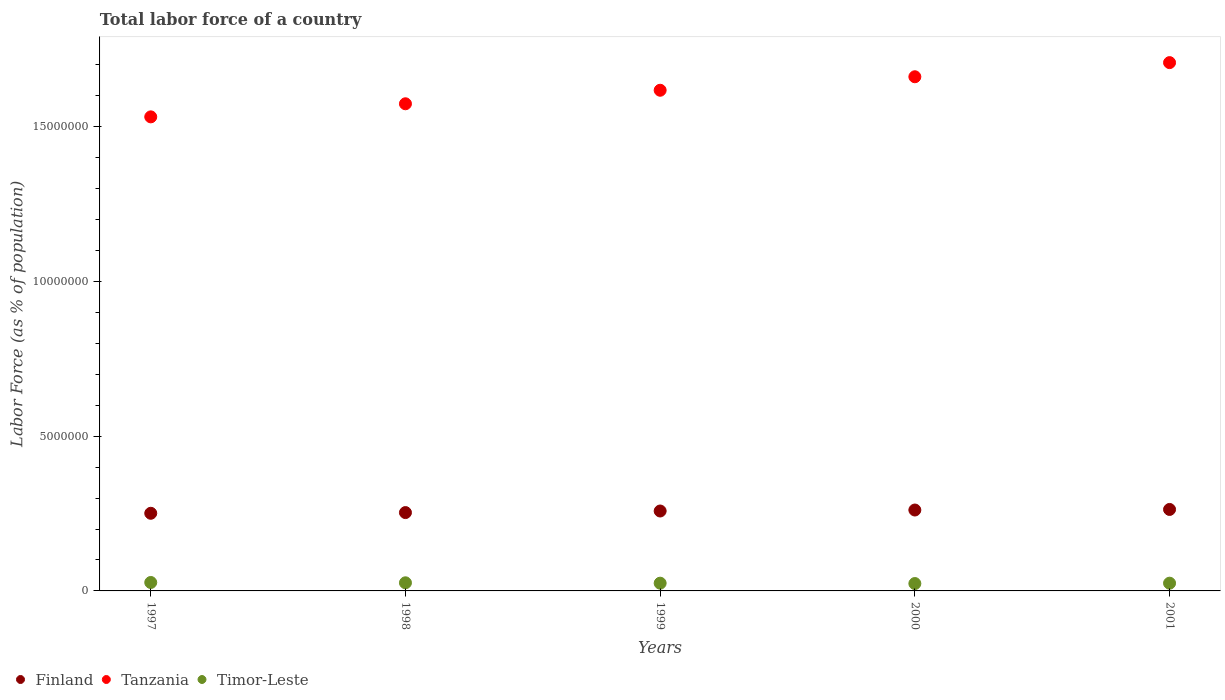What is the percentage of labor force in Tanzania in 2000?
Your response must be concise. 1.66e+07. Across all years, what is the maximum percentage of labor force in Tanzania?
Provide a short and direct response. 1.71e+07. Across all years, what is the minimum percentage of labor force in Tanzania?
Your answer should be very brief. 1.53e+07. In which year was the percentage of labor force in Tanzania maximum?
Offer a terse response. 2001. What is the total percentage of labor force in Timor-Leste in the graph?
Keep it short and to the point. 1.27e+06. What is the difference between the percentage of labor force in Tanzania in 1999 and that in 2000?
Your response must be concise. -4.36e+05. What is the difference between the percentage of labor force in Timor-Leste in 1998 and the percentage of labor force in Tanzania in 1999?
Offer a terse response. -1.59e+07. What is the average percentage of labor force in Tanzania per year?
Your answer should be very brief. 1.62e+07. In the year 1998, what is the difference between the percentage of labor force in Timor-Leste and percentage of labor force in Finland?
Provide a succinct answer. -2.27e+06. What is the ratio of the percentage of labor force in Tanzania in 1997 to that in 2000?
Offer a terse response. 0.92. Is the percentage of labor force in Finland in 1998 less than that in 2001?
Ensure brevity in your answer.  Yes. What is the difference between the highest and the second highest percentage of labor force in Timor-Leste?
Offer a very short reply. 1.02e+04. What is the difference between the highest and the lowest percentage of labor force in Tanzania?
Ensure brevity in your answer.  1.75e+06. In how many years, is the percentage of labor force in Timor-Leste greater than the average percentage of labor force in Timor-Leste taken over all years?
Your response must be concise. 2. Is the sum of the percentage of labor force in Finland in 1999 and 2000 greater than the maximum percentage of labor force in Timor-Leste across all years?
Your answer should be very brief. Yes. Does the percentage of labor force in Tanzania monotonically increase over the years?
Your response must be concise. Yes. Is the percentage of labor force in Timor-Leste strictly greater than the percentage of labor force in Tanzania over the years?
Make the answer very short. No. Is the percentage of labor force in Timor-Leste strictly less than the percentage of labor force in Finland over the years?
Your answer should be compact. Yes. How many dotlines are there?
Keep it short and to the point. 3. How many years are there in the graph?
Ensure brevity in your answer.  5. What is the difference between two consecutive major ticks on the Y-axis?
Offer a very short reply. 5.00e+06. Are the values on the major ticks of Y-axis written in scientific E-notation?
Provide a succinct answer. No. Does the graph contain any zero values?
Give a very brief answer. No. Where does the legend appear in the graph?
Ensure brevity in your answer.  Bottom left. How many legend labels are there?
Your answer should be compact. 3. What is the title of the graph?
Make the answer very short. Total labor force of a country. Does "Upper middle income" appear as one of the legend labels in the graph?
Make the answer very short. No. What is the label or title of the Y-axis?
Give a very brief answer. Labor Force (as % of population). What is the Labor Force (as % of population) of Finland in 1997?
Offer a very short reply. 2.51e+06. What is the Labor Force (as % of population) of Tanzania in 1997?
Your answer should be compact. 1.53e+07. What is the Labor Force (as % of population) in Timor-Leste in 1997?
Provide a succinct answer. 2.73e+05. What is the Labor Force (as % of population) of Finland in 1998?
Make the answer very short. 2.53e+06. What is the Labor Force (as % of population) of Tanzania in 1998?
Offer a very short reply. 1.57e+07. What is the Labor Force (as % of population) of Timor-Leste in 1998?
Keep it short and to the point. 2.62e+05. What is the Labor Force (as % of population) of Finland in 1999?
Offer a terse response. 2.58e+06. What is the Labor Force (as % of population) in Tanzania in 1999?
Your answer should be compact. 1.62e+07. What is the Labor Force (as % of population) in Timor-Leste in 1999?
Provide a short and direct response. 2.50e+05. What is the Labor Force (as % of population) in Finland in 2000?
Give a very brief answer. 2.61e+06. What is the Labor Force (as % of population) in Tanzania in 2000?
Give a very brief answer. 1.66e+07. What is the Labor Force (as % of population) of Timor-Leste in 2000?
Ensure brevity in your answer.  2.38e+05. What is the Labor Force (as % of population) of Finland in 2001?
Provide a succinct answer. 2.63e+06. What is the Labor Force (as % of population) of Tanzania in 2001?
Your answer should be very brief. 1.71e+07. What is the Labor Force (as % of population) in Timor-Leste in 2001?
Make the answer very short. 2.50e+05. Across all years, what is the maximum Labor Force (as % of population) of Finland?
Offer a terse response. 2.63e+06. Across all years, what is the maximum Labor Force (as % of population) in Tanzania?
Ensure brevity in your answer.  1.71e+07. Across all years, what is the maximum Labor Force (as % of population) of Timor-Leste?
Your response must be concise. 2.73e+05. Across all years, what is the minimum Labor Force (as % of population) in Finland?
Make the answer very short. 2.51e+06. Across all years, what is the minimum Labor Force (as % of population) of Tanzania?
Your answer should be compact. 1.53e+07. Across all years, what is the minimum Labor Force (as % of population) in Timor-Leste?
Give a very brief answer. 2.38e+05. What is the total Labor Force (as % of population) of Finland in the graph?
Make the answer very short. 1.29e+07. What is the total Labor Force (as % of population) in Tanzania in the graph?
Offer a very short reply. 8.09e+07. What is the total Labor Force (as % of population) of Timor-Leste in the graph?
Give a very brief answer. 1.27e+06. What is the difference between the Labor Force (as % of population) of Finland in 1997 and that in 1998?
Your response must be concise. -2.27e+04. What is the difference between the Labor Force (as % of population) of Tanzania in 1997 and that in 1998?
Give a very brief answer. -4.23e+05. What is the difference between the Labor Force (as % of population) in Timor-Leste in 1997 and that in 1998?
Keep it short and to the point. 1.02e+04. What is the difference between the Labor Force (as % of population) of Finland in 1997 and that in 1999?
Give a very brief answer. -7.36e+04. What is the difference between the Labor Force (as % of population) of Tanzania in 1997 and that in 1999?
Ensure brevity in your answer.  -8.60e+05. What is the difference between the Labor Force (as % of population) in Timor-Leste in 1997 and that in 1999?
Ensure brevity in your answer.  2.26e+04. What is the difference between the Labor Force (as % of population) in Finland in 1997 and that in 2000?
Keep it short and to the point. -1.06e+05. What is the difference between the Labor Force (as % of population) in Tanzania in 1997 and that in 2000?
Your response must be concise. -1.30e+06. What is the difference between the Labor Force (as % of population) of Timor-Leste in 1997 and that in 2000?
Your response must be concise. 3.43e+04. What is the difference between the Labor Force (as % of population) in Finland in 1997 and that in 2001?
Provide a short and direct response. -1.24e+05. What is the difference between the Labor Force (as % of population) of Tanzania in 1997 and that in 2001?
Offer a very short reply. -1.75e+06. What is the difference between the Labor Force (as % of population) of Timor-Leste in 1997 and that in 2001?
Provide a short and direct response. 2.25e+04. What is the difference between the Labor Force (as % of population) of Finland in 1998 and that in 1999?
Make the answer very short. -5.09e+04. What is the difference between the Labor Force (as % of population) in Tanzania in 1998 and that in 1999?
Make the answer very short. -4.37e+05. What is the difference between the Labor Force (as % of population) in Timor-Leste in 1998 and that in 1999?
Provide a short and direct response. 1.23e+04. What is the difference between the Labor Force (as % of population) of Finland in 1998 and that in 2000?
Keep it short and to the point. -8.28e+04. What is the difference between the Labor Force (as % of population) of Tanzania in 1998 and that in 2000?
Your response must be concise. -8.73e+05. What is the difference between the Labor Force (as % of population) in Timor-Leste in 1998 and that in 2000?
Offer a terse response. 2.40e+04. What is the difference between the Labor Force (as % of population) of Finland in 1998 and that in 2001?
Keep it short and to the point. -1.01e+05. What is the difference between the Labor Force (as % of population) of Tanzania in 1998 and that in 2001?
Offer a very short reply. -1.33e+06. What is the difference between the Labor Force (as % of population) in Timor-Leste in 1998 and that in 2001?
Provide a succinct answer. 1.23e+04. What is the difference between the Labor Force (as % of population) in Finland in 1999 and that in 2000?
Give a very brief answer. -3.19e+04. What is the difference between the Labor Force (as % of population) of Tanzania in 1999 and that in 2000?
Give a very brief answer. -4.36e+05. What is the difference between the Labor Force (as % of population) in Timor-Leste in 1999 and that in 2000?
Ensure brevity in your answer.  1.17e+04. What is the difference between the Labor Force (as % of population) in Finland in 1999 and that in 2001?
Give a very brief answer. -5.03e+04. What is the difference between the Labor Force (as % of population) in Tanzania in 1999 and that in 2001?
Offer a terse response. -8.93e+05. What is the difference between the Labor Force (as % of population) in Finland in 2000 and that in 2001?
Your answer should be very brief. -1.84e+04. What is the difference between the Labor Force (as % of population) in Tanzania in 2000 and that in 2001?
Provide a succinct answer. -4.57e+05. What is the difference between the Labor Force (as % of population) in Timor-Leste in 2000 and that in 2001?
Offer a terse response. -1.17e+04. What is the difference between the Labor Force (as % of population) of Finland in 1997 and the Labor Force (as % of population) of Tanzania in 1998?
Your response must be concise. -1.32e+07. What is the difference between the Labor Force (as % of population) in Finland in 1997 and the Labor Force (as % of population) in Timor-Leste in 1998?
Your response must be concise. 2.25e+06. What is the difference between the Labor Force (as % of population) of Tanzania in 1997 and the Labor Force (as % of population) of Timor-Leste in 1998?
Make the answer very short. 1.51e+07. What is the difference between the Labor Force (as % of population) in Finland in 1997 and the Labor Force (as % of population) in Tanzania in 1999?
Ensure brevity in your answer.  -1.37e+07. What is the difference between the Labor Force (as % of population) in Finland in 1997 and the Labor Force (as % of population) in Timor-Leste in 1999?
Provide a short and direct response. 2.26e+06. What is the difference between the Labor Force (as % of population) of Tanzania in 1997 and the Labor Force (as % of population) of Timor-Leste in 1999?
Ensure brevity in your answer.  1.51e+07. What is the difference between the Labor Force (as % of population) of Finland in 1997 and the Labor Force (as % of population) of Tanzania in 2000?
Offer a very short reply. -1.41e+07. What is the difference between the Labor Force (as % of population) in Finland in 1997 and the Labor Force (as % of population) in Timor-Leste in 2000?
Keep it short and to the point. 2.27e+06. What is the difference between the Labor Force (as % of population) in Tanzania in 1997 and the Labor Force (as % of population) in Timor-Leste in 2000?
Your answer should be very brief. 1.51e+07. What is the difference between the Labor Force (as % of population) in Finland in 1997 and the Labor Force (as % of population) in Tanzania in 2001?
Keep it short and to the point. -1.46e+07. What is the difference between the Labor Force (as % of population) of Finland in 1997 and the Labor Force (as % of population) of Timor-Leste in 2001?
Your answer should be very brief. 2.26e+06. What is the difference between the Labor Force (as % of population) of Tanzania in 1997 and the Labor Force (as % of population) of Timor-Leste in 2001?
Your response must be concise. 1.51e+07. What is the difference between the Labor Force (as % of population) of Finland in 1998 and the Labor Force (as % of population) of Tanzania in 1999?
Offer a terse response. -1.36e+07. What is the difference between the Labor Force (as % of population) in Finland in 1998 and the Labor Force (as % of population) in Timor-Leste in 1999?
Your answer should be very brief. 2.28e+06. What is the difference between the Labor Force (as % of population) in Tanzania in 1998 and the Labor Force (as % of population) in Timor-Leste in 1999?
Your answer should be very brief. 1.55e+07. What is the difference between the Labor Force (as % of population) in Finland in 1998 and the Labor Force (as % of population) in Tanzania in 2000?
Offer a very short reply. -1.41e+07. What is the difference between the Labor Force (as % of population) in Finland in 1998 and the Labor Force (as % of population) in Timor-Leste in 2000?
Your answer should be very brief. 2.29e+06. What is the difference between the Labor Force (as % of population) in Tanzania in 1998 and the Labor Force (as % of population) in Timor-Leste in 2000?
Your response must be concise. 1.55e+07. What is the difference between the Labor Force (as % of population) of Finland in 1998 and the Labor Force (as % of population) of Tanzania in 2001?
Ensure brevity in your answer.  -1.45e+07. What is the difference between the Labor Force (as % of population) of Finland in 1998 and the Labor Force (as % of population) of Timor-Leste in 2001?
Your response must be concise. 2.28e+06. What is the difference between the Labor Force (as % of population) in Tanzania in 1998 and the Labor Force (as % of population) in Timor-Leste in 2001?
Offer a very short reply. 1.55e+07. What is the difference between the Labor Force (as % of population) in Finland in 1999 and the Labor Force (as % of population) in Tanzania in 2000?
Your answer should be very brief. -1.40e+07. What is the difference between the Labor Force (as % of population) in Finland in 1999 and the Labor Force (as % of population) in Timor-Leste in 2000?
Give a very brief answer. 2.34e+06. What is the difference between the Labor Force (as % of population) of Tanzania in 1999 and the Labor Force (as % of population) of Timor-Leste in 2000?
Offer a terse response. 1.59e+07. What is the difference between the Labor Force (as % of population) in Finland in 1999 and the Labor Force (as % of population) in Tanzania in 2001?
Keep it short and to the point. -1.45e+07. What is the difference between the Labor Force (as % of population) in Finland in 1999 and the Labor Force (as % of population) in Timor-Leste in 2001?
Provide a succinct answer. 2.33e+06. What is the difference between the Labor Force (as % of population) in Tanzania in 1999 and the Labor Force (as % of population) in Timor-Leste in 2001?
Make the answer very short. 1.59e+07. What is the difference between the Labor Force (as % of population) in Finland in 2000 and the Labor Force (as % of population) in Tanzania in 2001?
Your response must be concise. -1.45e+07. What is the difference between the Labor Force (as % of population) in Finland in 2000 and the Labor Force (as % of population) in Timor-Leste in 2001?
Make the answer very short. 2.36e+06. What is the difference between the Labor Force (as % of population) in Tanzania in 2000 and the Labor Force (as % of population) in Timor-Leste in 2001?
Offer a very short reply. 1.64e+07. What is the average Labor Force (as % of population) in Finland per year?
Make the answer very short. 2.57e+06. What is the average Labor Force (as % of population) in Tanzania per year?
Your response must be concise. 1.62e+07. What is the average Labor Force (as % of population) of Timor-Leste per year?
Your answer should be compact. 2.55e+05. In the year 1997, what is the difference between the Labor Force (as % of population) in Finland and Labor Force (as % of population) in Tanzania?
Make the answer very short. -1.28e+07. In the year 1997, what is the difference between the Labor Force (as % of population) of Finland and Labor Force (as % of population) of Timor-Leste?
Keep it short and to the point. 2.24e+06. In the year 1997, what is the difference between the Labor Force (as % of population) in Tanzania and Labor Force (as % of population) in Timor-Leste?
Provide a short and direct response. 1.50e+07. In the year 1998, what is the difference between the Labor Force (as % of population) of Finland and Labor Force (as % of population) of Tanzania?
Keep it short and to the point. -1.32e+07. In the year 1998, what is the difference between the Labor Force (as % of population) of Finland and Labor Force (as % of population) of Timor-Leste?
Give a very brief answer. 2.27e+06. In the year 1998, what is the difference between the Labor Force (as % of population) of Tanzania and Labor Force (as % of population) of Timor-Leste?
Your response must be concise. 1.55e+07. In the year 1999, what is the difference between the Labor Force (as % of population) in Finland and Labor Force (as % of population) in Tanzania?
Offer a terse response. -1.36e+07. In the year 1999, what is the difference between the Labor Force (as % of population) of Finland and Labor Force (as % of population) of Timor-Leste?
Make the answer very short. 2.33e+06. In the year 1999, what is the difference between the Labor Force (as % of population) in Tanzania and Labor Force (as % of population) in Timor-Leste?
Offer a very short reply. 1.59e+07. In the year 2000, what is the difference between the Labor Force (as % of population) in Finland and Labor Force (as % of population) in Tanzania?
Your answer should be very brief. -1.40e+07. In the year 2000, what is the difference between the Labor Force (as % of population) in Finland and Labor Force (as % of population) in Timor-Leste?
Your answer should be very brief. 2.38e+06. In the year 2000, what is the difference between the Labor Force (as % of population) in Tanzania and Labor Force (as % of population) in Timor-Leste?
Give a very brief answer. 1.64e+07. In the year 2001, what is the difference between the Labor Force (as % of population) in Finland and Labor Force (as % of population) in Tanzania?
Keep it short and to the point. -1.44e+07. In the year 2001, what is the difference between the Labor Force (as % of population) of Finland and Labor Force (as % of population) of Timor-Leste?
Your answer should be compact. 2.38e+06. In the year 2001, what is the difference between the Labor Force (as % of population) in Tanzania and Labor Force (as % of population) in Timor-Leste?
Offer a very short reply. 1.68e+07. What is the ratio of the Labor Force (as % of population) of Tanzania in 1997 to that in 1998?
Make the answer very short. 0.97. What is the ratio of the Labor Force (as % of population) in Timor-Leste in 1997 to that in 1998?
Make the answer very short. 1.04. What is the ratio of the Labor Force (as % of population) in Finland in 1997 to that in 1999?
Provide a short and direct response. 0.97. What is the ratio of the Labor Force (as % of population) in Tanzania in 1997 to that in 1999?
Provide a short and direct response. 0.95. What is the ratio of the Labor Force (as % of population) of Timor-Leste in 1997 to that in 1999?
Offer a very short reply. 1.09. What is the ratio of the Labor Force (as % of population) in Finland in 1997 to that in 2000?
Make the answer very short. 0.96. What is the ratio of the Labor Force (as % of population) of Tanzania in 1997 to that in 2000?
Keep it short and to the point. 0.92. What is the ratio of the Labor Force (as % of population) of Timor-Leste in 1997 to that in 2000?
Provide a short and direct response. 1.14. What is the ratio of the Labor Force (as % of population) of Finland in 1997 to that in 2001?
Your answer should be compact. 0.95. What is the ratio of the Labor Force (as % of population) in Tanzania in 1997 to that in 2001?
Provide a short and direct response. 0.9. What is the ratio of the Labor Force (as % of population) in Timor-Leste in 1997 to that in 2001?
Provide a succinct answer. 1.09. What is the ratio of the Labor Force (as % of population) of Finland in 1998 to that in 1999?
Provide a short and direct response. 0.98. What is the ratio of the Labor Force (as % of population) of Timor-Leste in 1998 to that in 1999?
Provide a succinct answer. 1.05. What is the ratio of the Labor Force (as % of population) of Finland in 1998 to that in 2000?
Keep it short and to the point. 0.97. What is the ratio of the Labor Force (as % of population) of Tanzania in 1998 to that in 2000?
Your answer should be very brief. 0.95. What is the ratio of the Labor Force (as % of population) of Timor-Leste in 1998 to that in 2000?
Ensure brevity in your answer.  1.1. What is the ratio of the Labor Force (as % of population) in Finland in 1998 to that in 2001?
Provide a succinct answer. 0.96. What is the ratio of the Labor Force (as % of population) in Tanzania in 1998 to that in 2001?
Make the answer very short. 0.92. What is the ratio of the Labor Force (as % of population) in Timor-Leste in 1998 to that in 2001?
Your answer should be very brief. 1.05. What is the ratio of the Labor Force (as % of population) of Tanzania in 1999 to that in 2000?
Provide a succinct answer. 0.97. What is the ratio of the Labor Force (as % of population) in Timor-Leste in 1999 to that in 2000?
Provide a short and direct response. 1.05. What is the ratio of the Labor Force (as % of population) of Finland in 1999 to that in 2001?
Keep it short and to the point. 0.98. What is the ratio of the Labor Force (as % of population) of Tanzania in 1999 to that in 2001?
Your response must be concise. 0.95. What is the ratio of the Labor Force (as % of population) of Tanzania in 2000 to that in 2001?
Your response must be concise. 0.97. What is the ratio of the Labor Force (as % of population) of Timor-Leste in 2000 to that in 2001?
Your answer should be compact. 0.95. What is the difference between the highest and the second highest Labor Force (as % of population) of Finland?
Provide a short and direct response. 1.84e+04. What is the difference between the highest and the second highest Labor Force (as % of population) of Tanzania?
Give a very brief answer. 4.57e+05. What is the difference between the highest and the second highest Labor Force (as % of population) in Timor-Leste?
Keep it short and to the point. 1.02e+04. What is the difference between the highest and the lowest Labor Force (as % of population) of Finland?
Offer a terse response. 1.24e+05. What is the difference between the highest and the lowest Labor Force (as % of population) of Tanzania?
Your response must be concise. 1.75e+06. What is the difference between the highest and the lowest Labor Force (as % of population) of Timor-Leste?
Make the answer very short. 3.43e+04. 